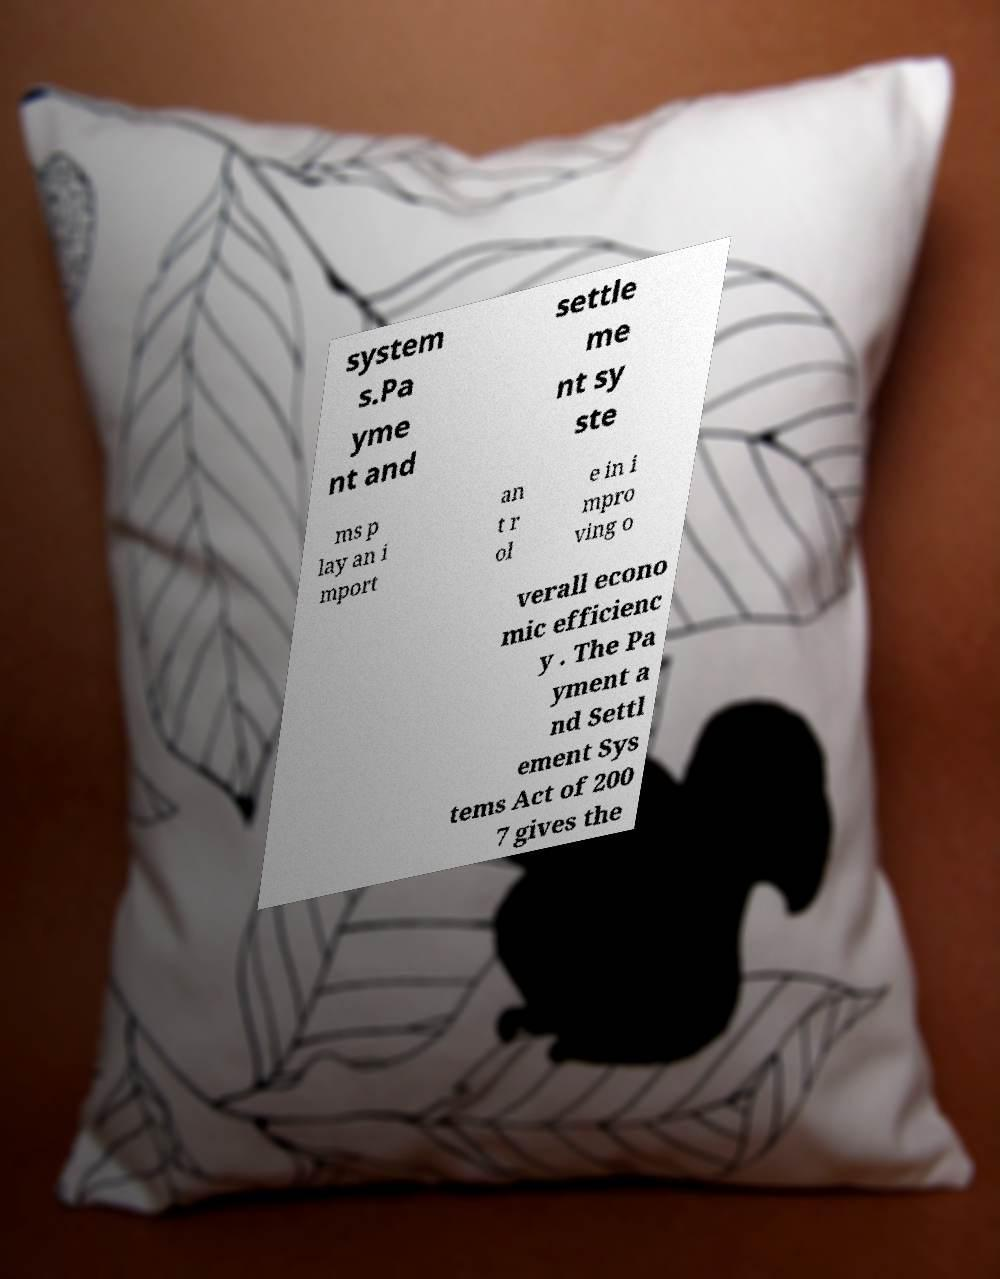Could you extract and type out the text from this image? system s.Pa yme nt and settle me nt sy ste ms p lay an i mport an t r ol e in i mpro ving o verall econo mic efficienc y . The Pa yment a nd Settl ement Sys tems Act of 200 7 gives the 